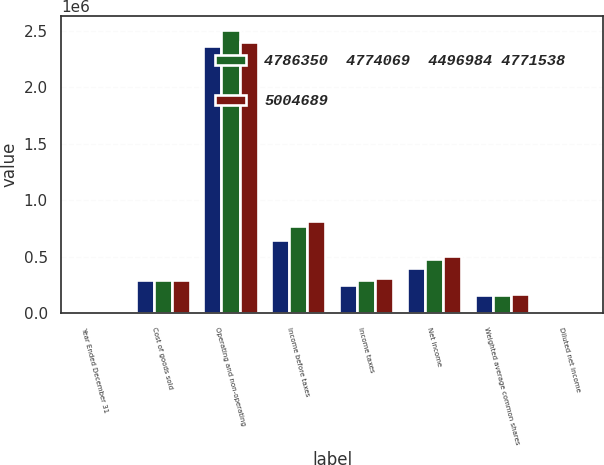Convert chart. <chart><loc_0><loc_0><loc_500><loc_500><stacked_bar_chart><ecel><fcel>Year Ended December 31<fcel>Cost of goods sold<fcel>Operating and non-operating<fcel>Income before taxes<fcel>Income taxes<fcel>Net income<fcel>Weighted average common shares<fcel>Diluted net income<nl><fcel>nan<fcel>2009<fcel>293051<fcel>2.3656e+06<fcel>644165<fcel>244590<fcel>399575<fcel>159707<fcel>2.5<nl><fcel>4786350  4774069  4496984 4771538<fcel>2008<fcel>293051<fcel>2.50402e+06<fcel>768468<fcel>293051<fcel>475417<fcel>162986<fcel>2.92<nl><fcel>5004689<fcel>2007<fcel>293051<fcel>2.40048e+06<fcel>816745<fcel>310406<fcel>506339<fcel>170135<fcel>2.98<nl></chart> 